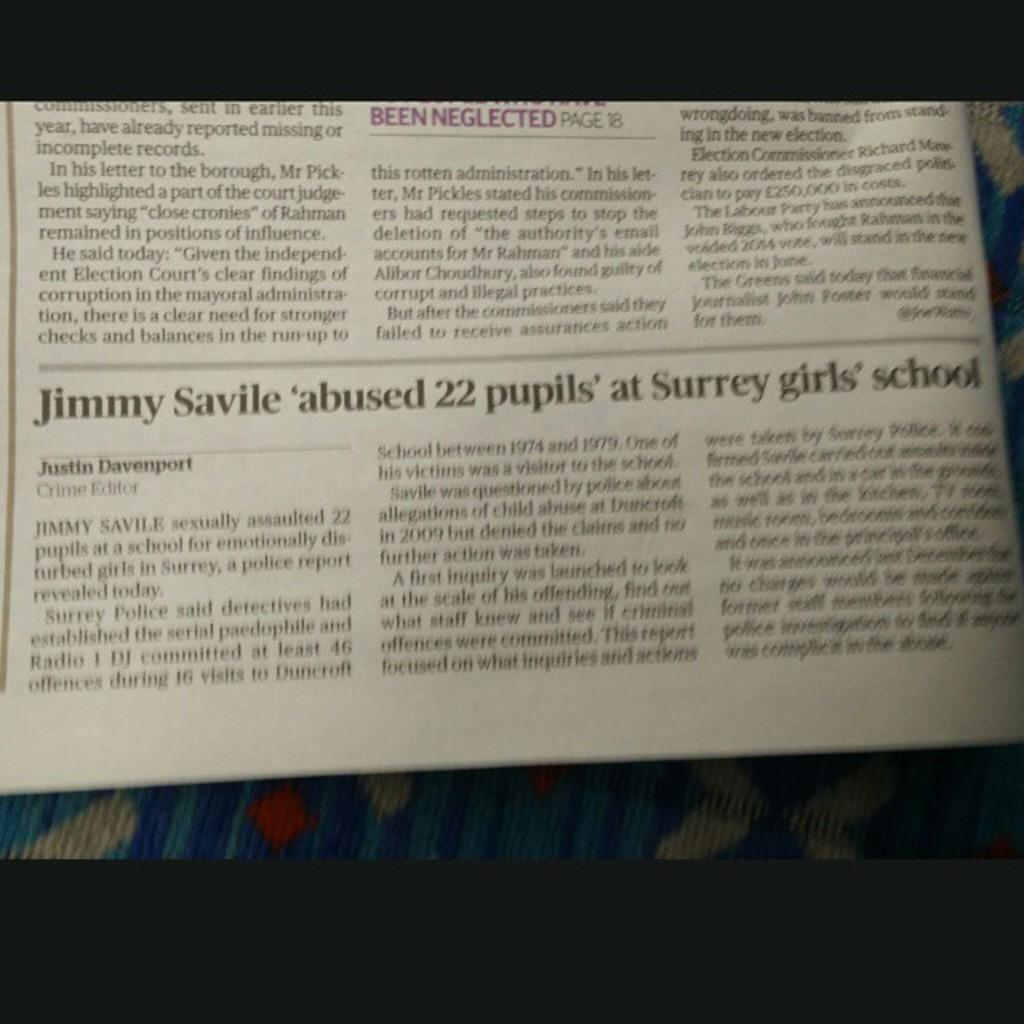<image>
Give a short and clear explanation of the subsequent image. A print newspaper article about Jimmy Savile abusing girls. 